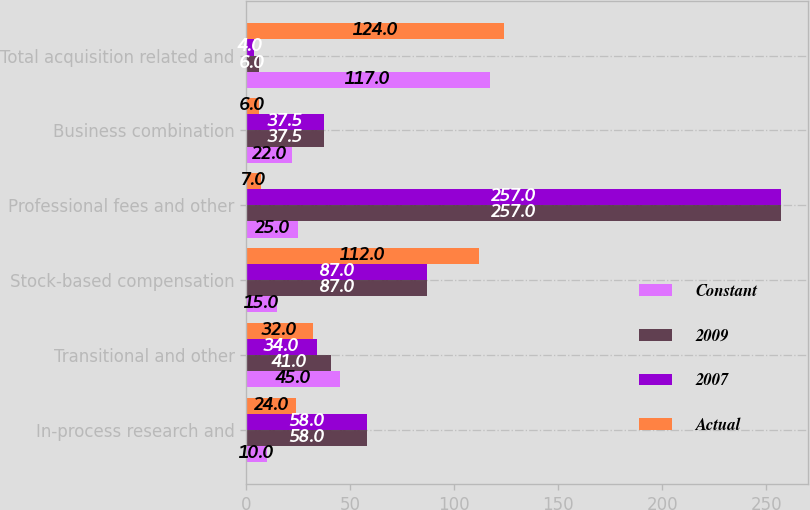<chart> <loc_0><loc_0><loc_500><loc_500><stacked_bar_chart><ecel><fcel>In-process research and<fcel>Transitional and other<fcel>Stock-based compensation<fcel>Professional fees and other<fcel>Business combination<fcel>Total acquisition related and<nl><fcel>Constant<fcel>10<fcel>45<fcel>15<fcel>25<fcel>22<fcel>117<nl><fcel>2009<fcel>58<fcel>41<fcel>87<fcel>257<fcel>37.5<fcel>6<nl><fcel>2007<fcel>58<fcel>34<fcel>87<fcel>257<fcel>37.5<fcel>4<nl><fcel>Actual<fcel>24<fcel>32<fcel>112<fcel>7<fcel>6<fcel>124<nl></chart> 